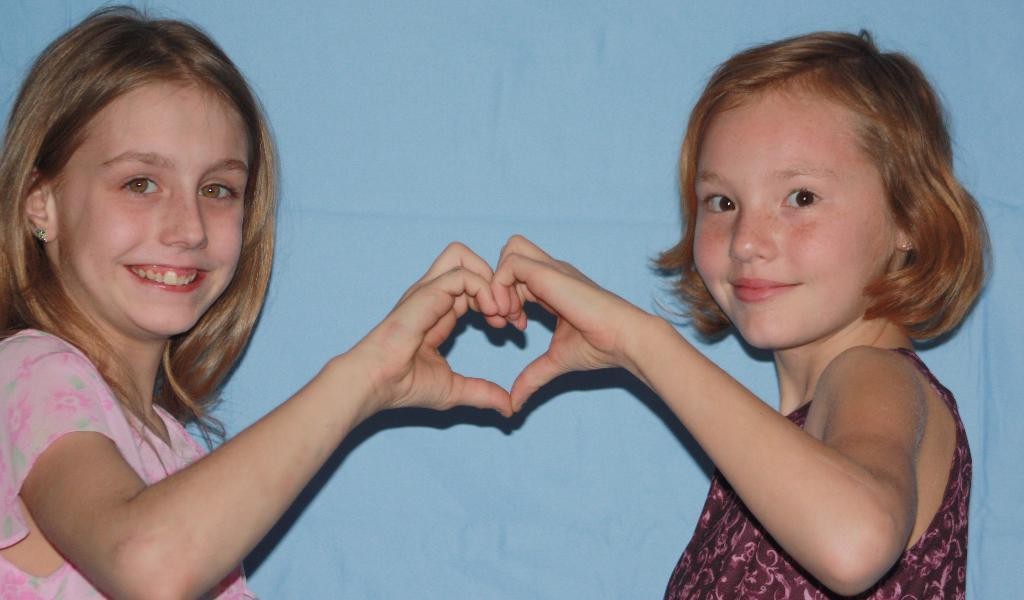How many children are present in the image? There are two children in the image. What is the facial expression of the children? The children are smiling. What action are the children performing with their hands? The children are making a heart shape with their hands. What can be seen in the background of the image? There is a wall in the background of the image. What type of canvas is being used for the afterthought discussion in the image? There is no canvas or discussion present in the image; it features two children making a heart shape with their hands. 